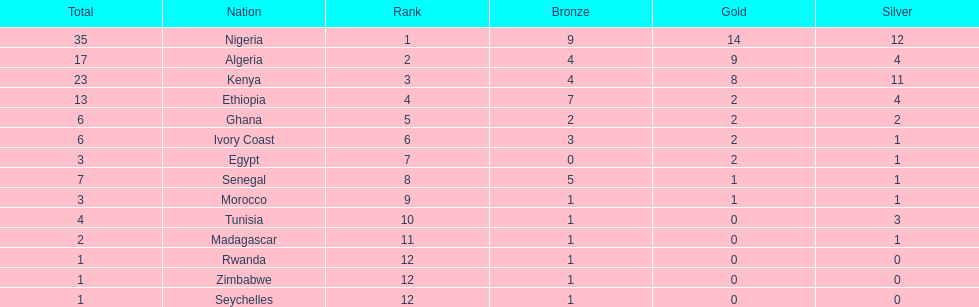What was the total number of medals the ivory coast won? 6. 